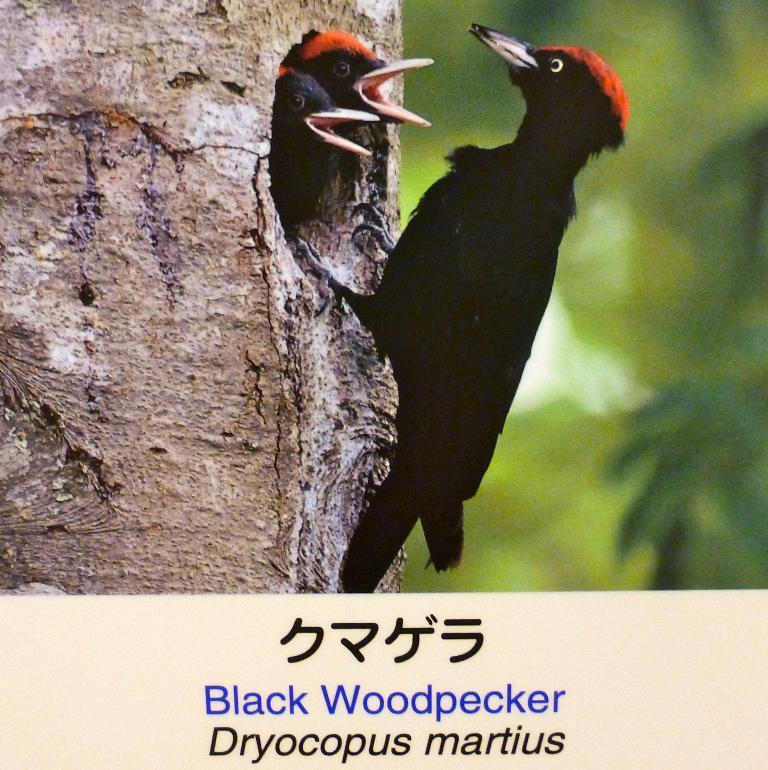What type of birds are on the tree in the image? There are three woodpeckers on the tree in the image. Can you describe the background of the image? The background of the image is blurred. Is there any text visible in the image? Yes, there is some text visible on the image. How many apples are on the tree in the image? There are no apples visible in the image; it features three woodpeckers on a tree. What type of flame can be seen near the woodpeckers in the image? There is no flame present in the image; it only features woodpeckers on a tree and some text. 